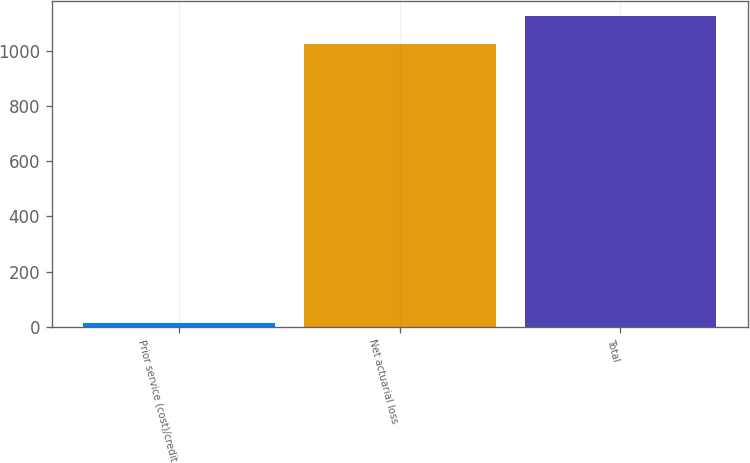Convert chart to OTSL. <chart><loc_0><loc_0><loc_500><loc_500><bar_chart><fcel>Prior service (cost)/credit<fcel>Net actuarial loss<fcel>Total<nl><fcel>12<fcel>1023<fcel>1125.3<nl></chart> 